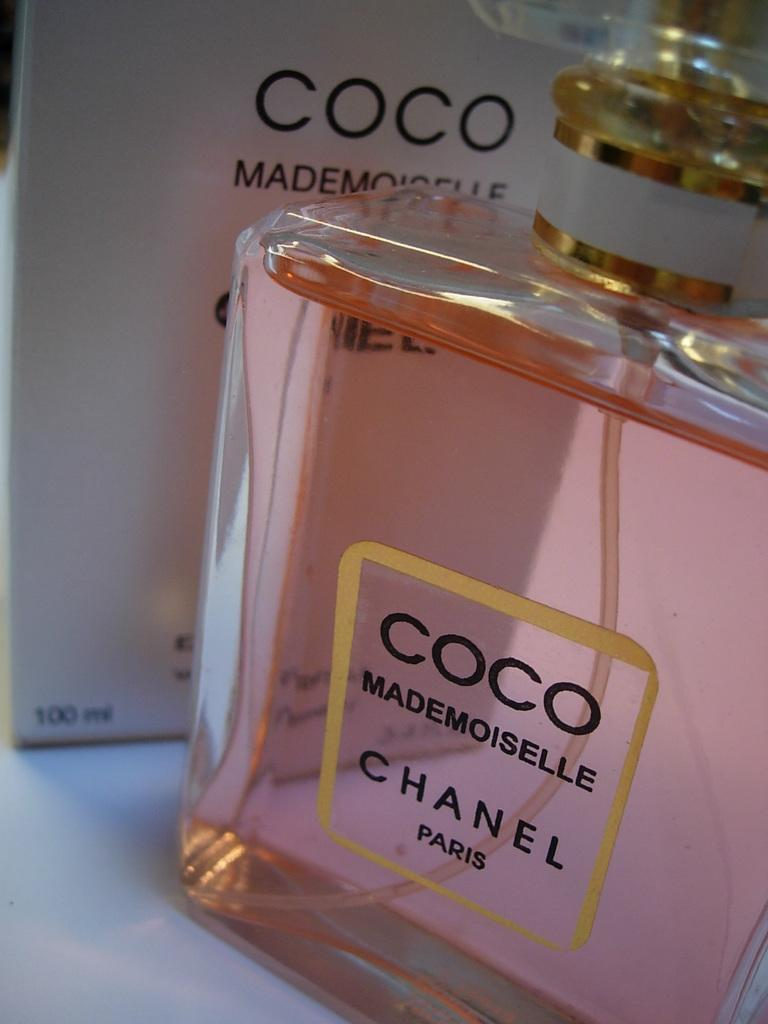<image>
Give a short and clear explanation of the subsequent image. A bottle of perfume has the Coco Chanel logo on it. 